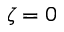Convert formula to latex. <formula><loc_0><loc_0><loc_500><loc_500>\zeta = 0</formula> 